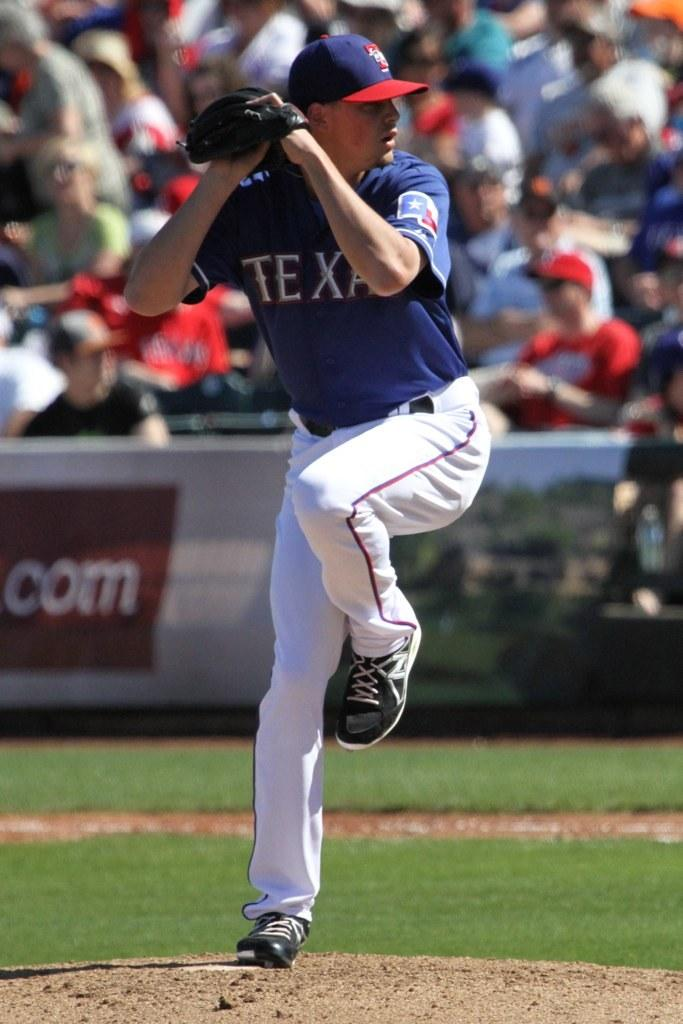<image>
Render a clear and concise summary of the photo. texas pitcher in blue and white uniform getting ready to throw the ball 